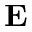Convert formula to latex. <formula><loc_0><loc_0><loc_500><loc_500>E</formula> 